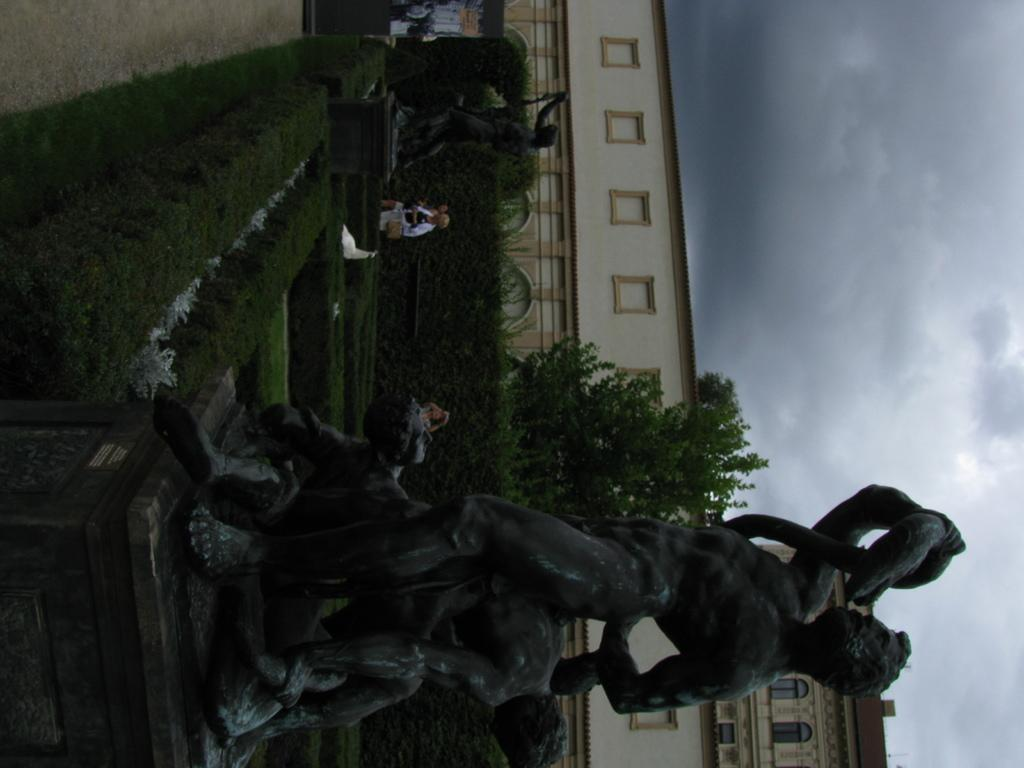What is the main subject in the center of the image? There are statues in the center of the image. What type of vegetation can be seen in the image? There are trees and plants in the image. Are there any people present in the image? Yes, there are people standing in the image. What can be seen in the background of the image? There is a sky, clouds, and a building visible in the background of the image. How many gloves are being held by the people in the image? There is no mention of gloves in the image, so it cannot be determined how many gloves are being held. 